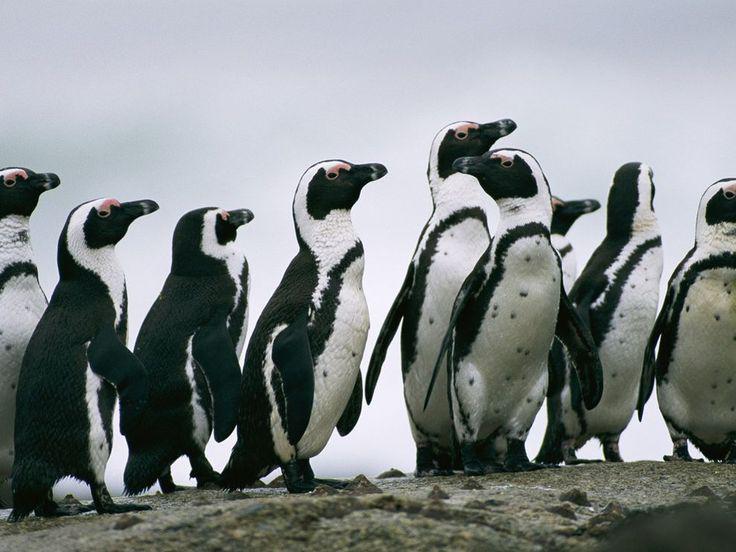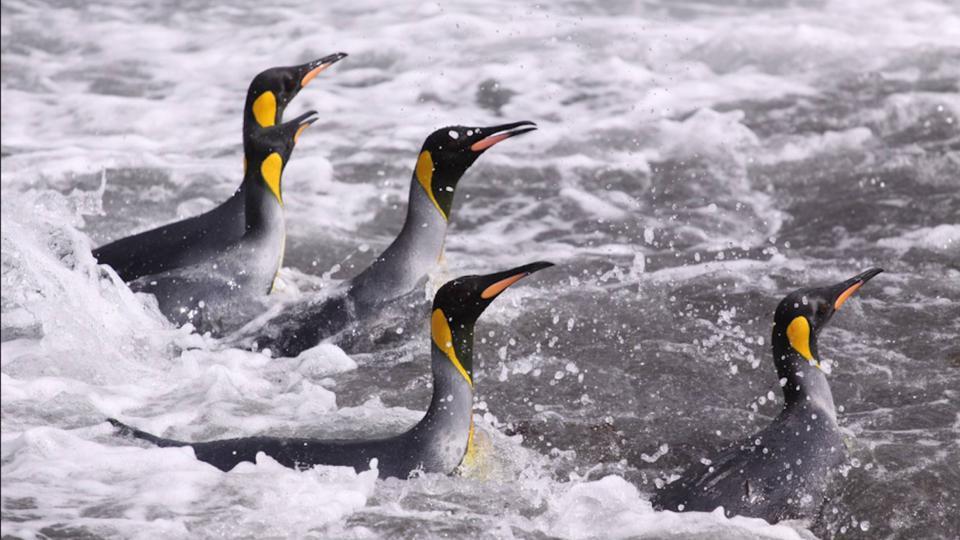The first image is the image on the left, the second image is the image on the right. Evaluate the accuracy of this statement regarding the images: "The penguins in one image are in splashing water, while those in the other image are standing on solid, dry ground.". Is it true? Answer yes or no. Yes. 